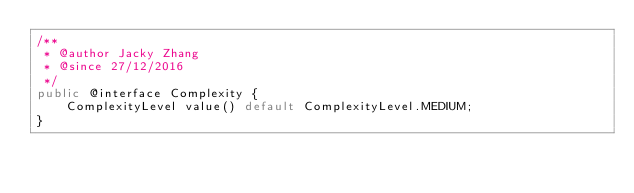Convert code to text. <code><loc_0><loc_0><loc_500><loc_500><_Java_>/**
 * @author Jacky Zhang
 * @since 27/12/2016
 */
public @interface Complexity {
    ComplexityLevel value() default ComplexityLevel.MEDIUM;
}
</code> 